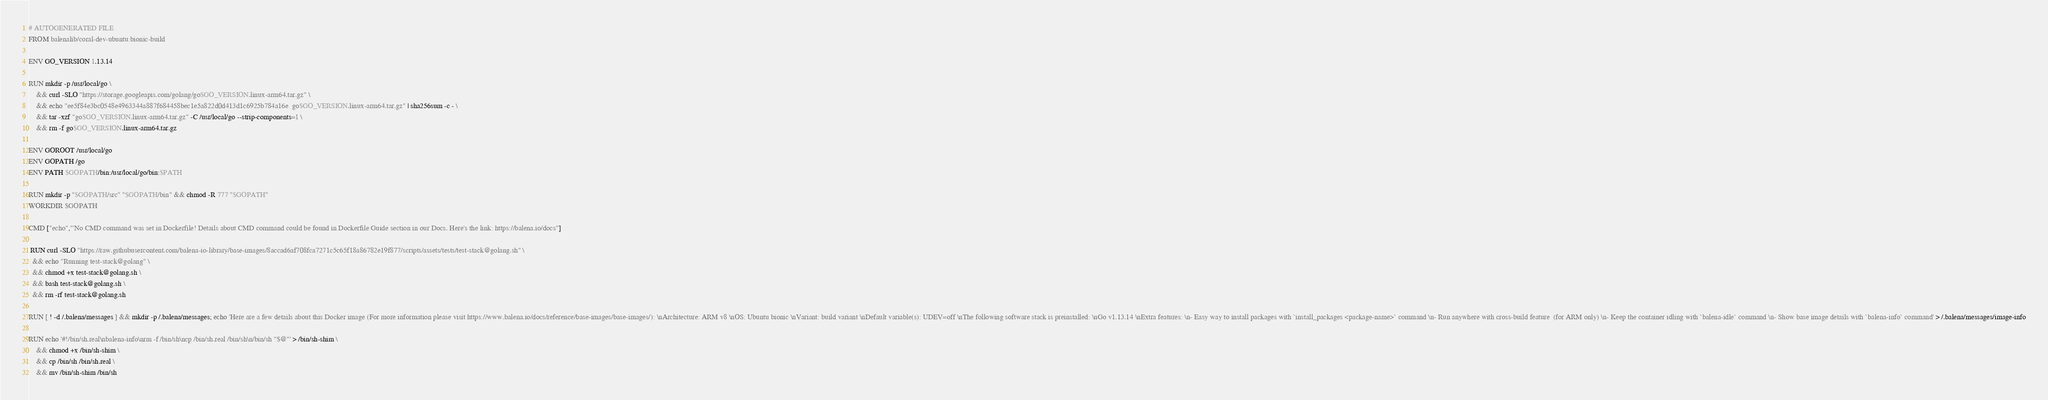<code> <loc_0><loc_0><loc_500><loc_500><_Dockerfile_># AUTOGENERATED FILE
FROM balenalib/coral-dev-ubuntu:bionic-build

ENV GO_VERSION 1.13.14

RUN mkdir -p /usr/local/go \
	&& curl -SLO "https://storage.googleapis.com/golang/go$GO_VERSION.linux-arm64.tar.gz" \
	&& echo "ee5f84e3bc0548e4963344a887f684458bec1e5a822d0d413d1c6925b784a16e  go$GO_VERSION.linux-arm64.tar.gz" | sha256sum -c - \
	&& tar -xzf "go$GO_VERSION.linux-arm64.tar.gz" -C /usr/local/go --strip-components=1 \
	&& rm -f go$GO_VERSION.linux-arm64.tar.gz

ENV GOROOT /usr/local/go
ENV GOPATH /go
ENV PATH $GOPATH/bin:/usr/local/go/bin:$PATH

RUN mkdir -p "$GOPATH/src" "$GOPATH/bin" && chmod -R 777 "$GOPATH"
WORKDIR $GOPATH

CMD ["echo","'No CMD command was set in Dockerfile! Details about CMD command could be found in Dockerfile Guide section in our Docs. Here's the link: https://balena.io/docs"]

 RUN curl -SLO "https://raw.githubusercontent.com/balena-io-library/base-images/8accad6af708fca7271c5c65f18a86782e19f877/scripts/assets/tests/test-stack@golang.sh" \
  && echo "Running test-stack@golang" \
  && chmod +x test-stack@golang.sh \
  && bash test-stack@golang.sh \
  && rm -rf test-stack@golang.sh 

RUN [ ! -d /.balena/messages ] && mkdir -p /.balena/messages; echo 'Here are a few details about this Docker image (For more information please visit https://www.balena.io/docs/reference/base-images/base-images/): \nArchitecture: ARM v8 \nOS: Ubuntu bionic \nVariant: build variant \nDefault variable(s): UDEV=off \nThe following software stack is preinstalled: \nGo v1.13.14 \nExtra features: \n- Easy way to install packages with `install_packages <package-name>` command \n- Run anywhere with cross-build feature  (for ARM only) \n- Keep the container idling with `balena-idle` command \n- Show base image details with `balena-info` command' > /.balena/messages/image-info

RUN echo '#!/bin/sh.real\nbalena-info\nrm -f /bin/sh\ncp /bin/sh.real /bin/sh\n/bin/sh "$@"' > /bin/sh-shim \
	&& chmod +x /bin/sh-shim \
	&& cp /bin/sh /bin/sh.real \
	&& mv /bin/sh-shim /bin/sh</code> 